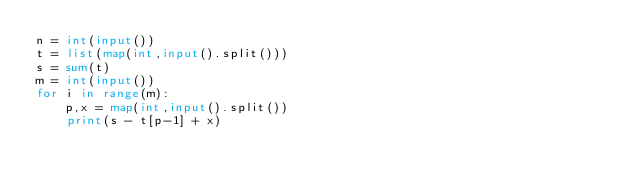<code> <loc_0><loc_0><loc_500><loc_500><_Python_>n = int(input())
t = list(map(int,input().split()))
s = sum(t)
m = int(input())
for i in range(m):
    p,x = map(int,input().split())
    print(s - t[p-1] + x)
</code> 